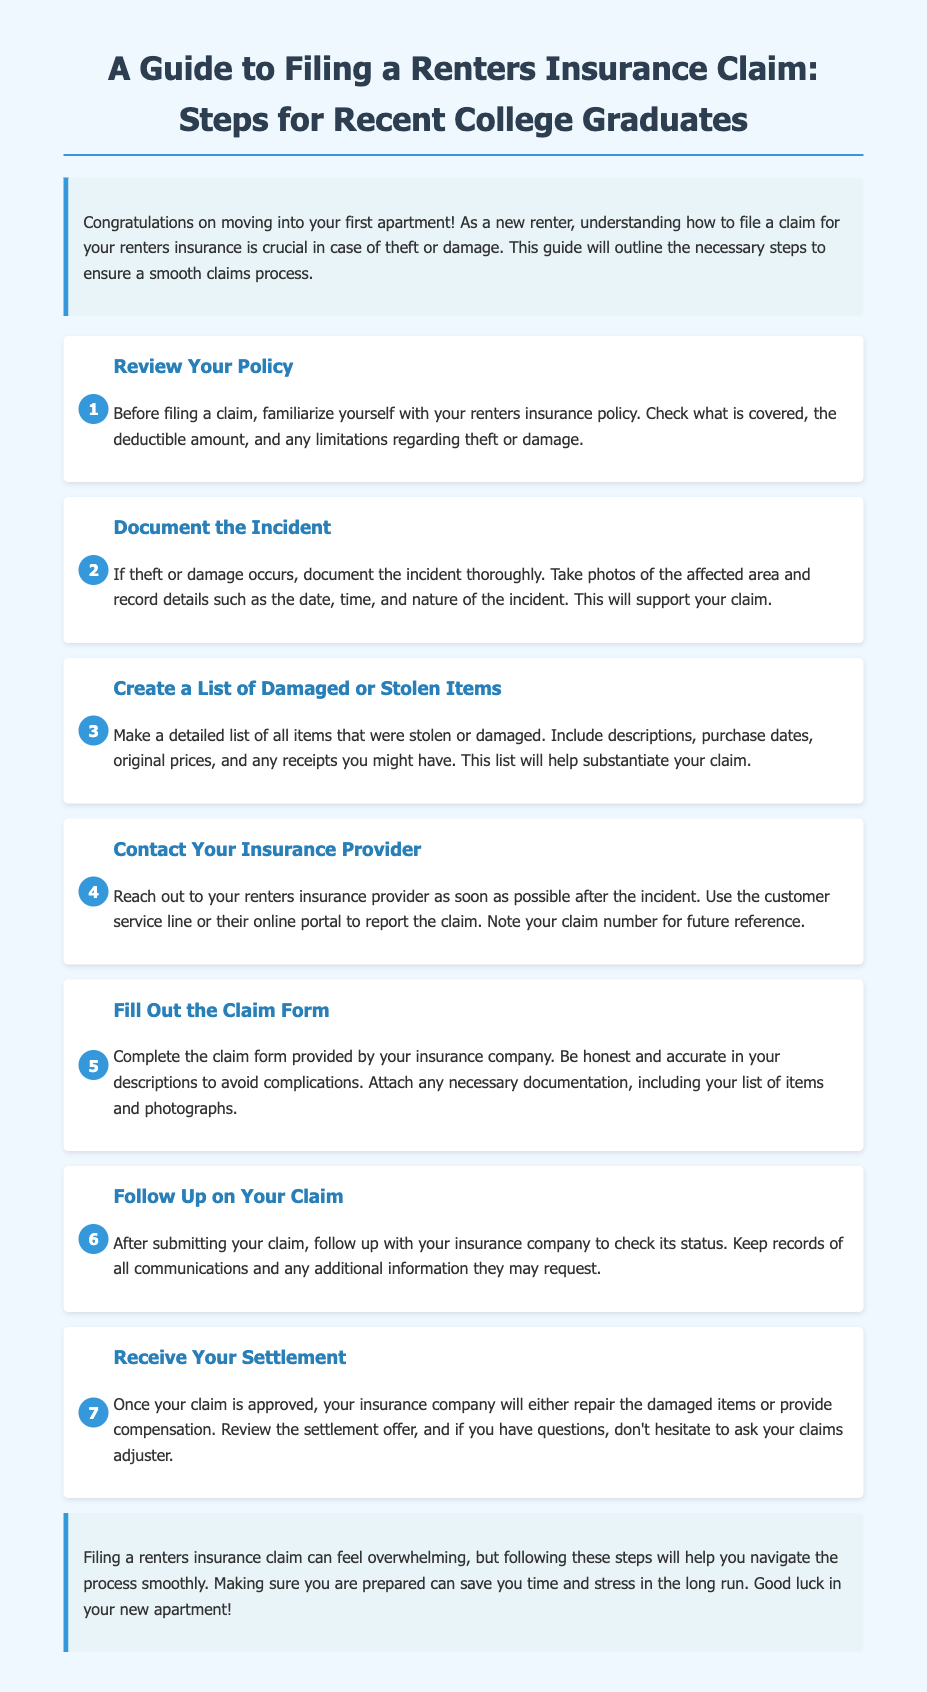What is the title of the document? The title is presented at the top of the document, indicating the topic covered.
Answer: A Guide to Filing a Renters Insurance Claim: Steps for Recent College Graduates What is the first step in filing a claim? The first step is clearly stated in the guide, outlining what to do first.
Answer: Review Your Policy How many steps are outlined in the guide? The total number of steps is indicated by the number of sections in the document that detail the claims process.
Answer: 7 What type of documentation should be gathered after an incident? The document specifies the type of information you need to collect when an incident occurs.
Answer: Photos and details of the incident What should you do if you have questions about your settlement? The document advises what to do if you require further clarification regarding the settlement offer.
Answer: Ask your claims adjuster What should be included in the list of damaged or stolen items? The guide details what to include when compiling this list to support the insurance claim.
Answer: Descriptions, purchase dates, original prices, and receipts What is the concluding advice given in the guide? The conclusion recaps the overall sentiment and suggestion for renters regarding the claims process.
Answer: Be prepared to save time and stress 